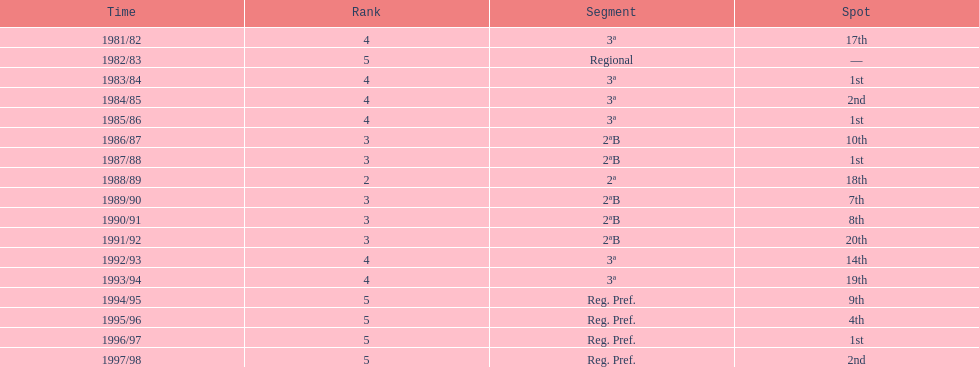How many times total did they finish first 4. 